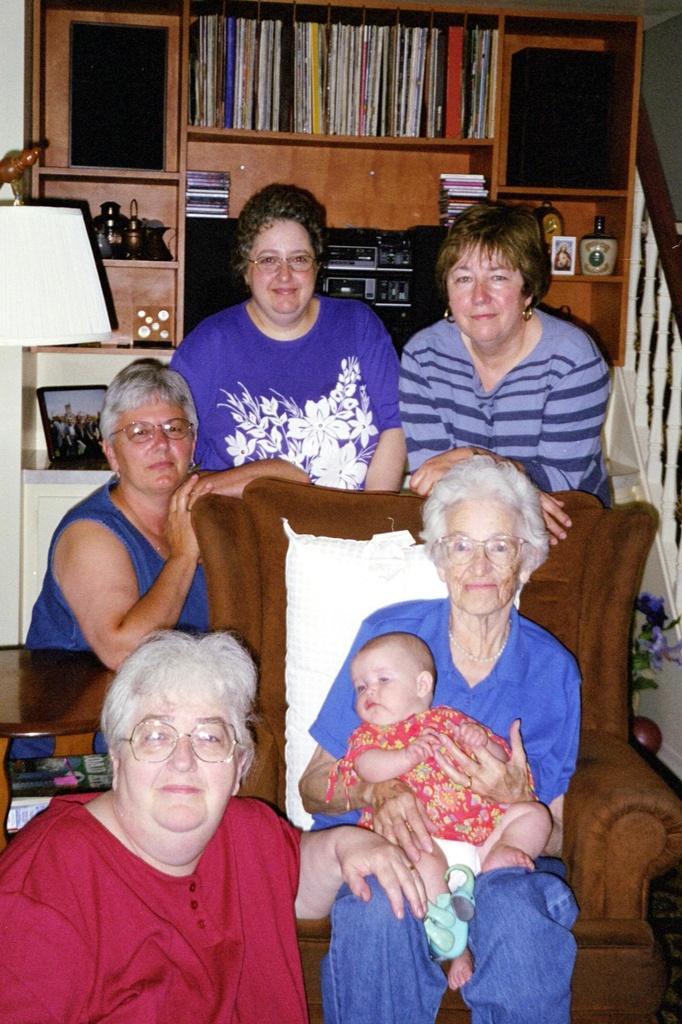Can you describe this image briefly? In this picture we can see a group of people. A woman is holding a baby and she is sitting on a chair. Behind the people there are books and some objects in the shelves. On the left side of the image, there is a table. On the right side of the image, there is a baluster. 